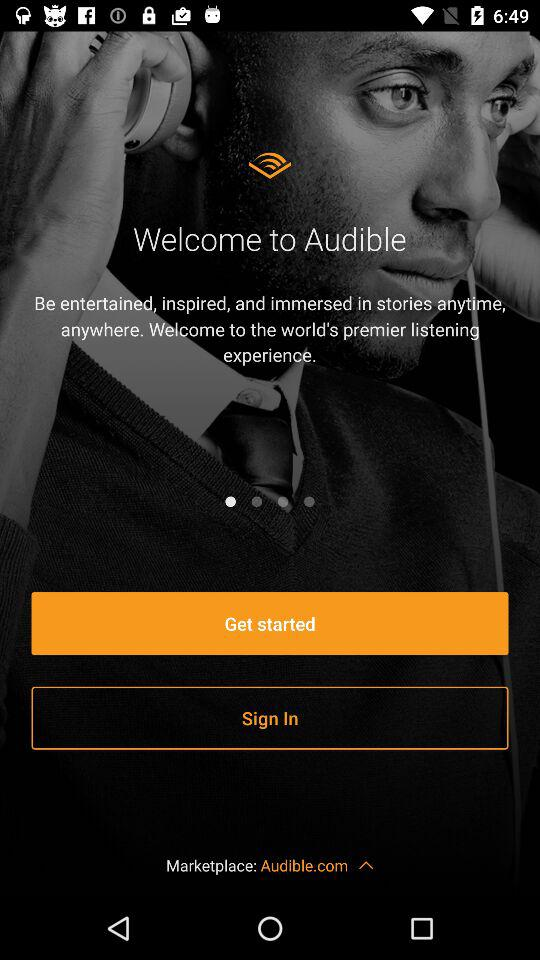What is the application name? The application name is "Audible". 